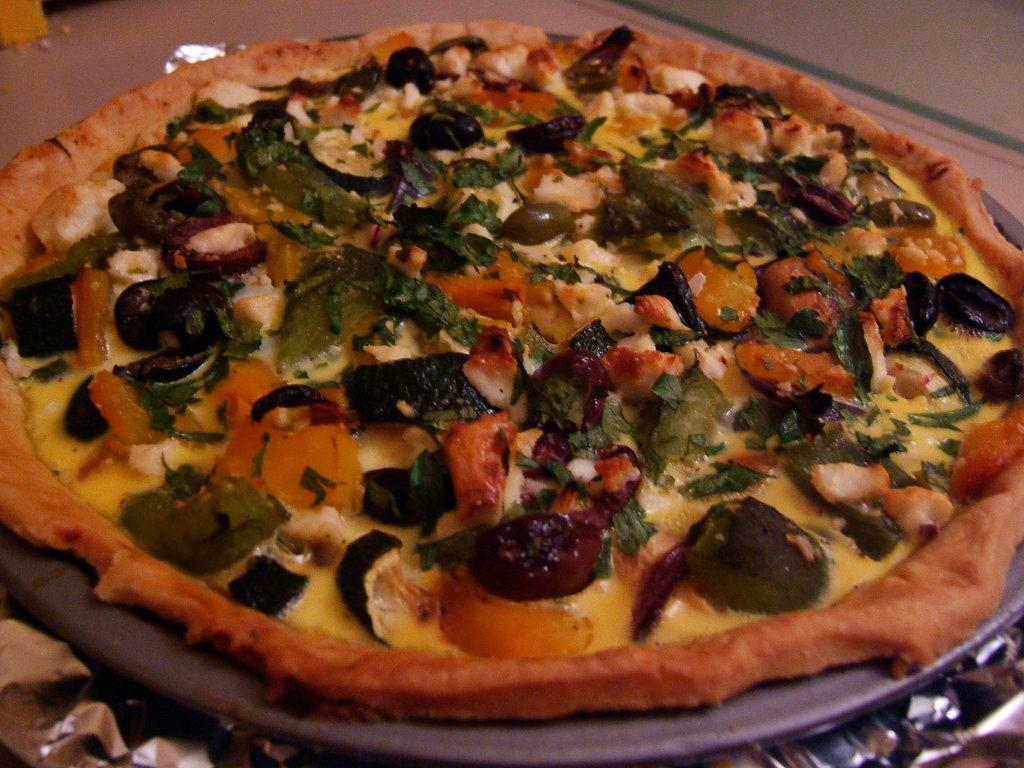What type of food is the main subject of the image? There is a pizza in the image. How many toppings are visible on the pizza? The pizza has many toppings. What is one specific ingredient that can be seen on the pizza? The pizza has cheese on it. What is the pizza placed on in the image? The pizza is on a pan. What type of air can be seen surrounding the pizza in the image? There is no air visible in the image; it is a picture of a pizza on a pan. How does the pizza aid in the digestion process in the image? The image does not show the pizza being consumed or digested; it is a static image of a pizza on a pan. 